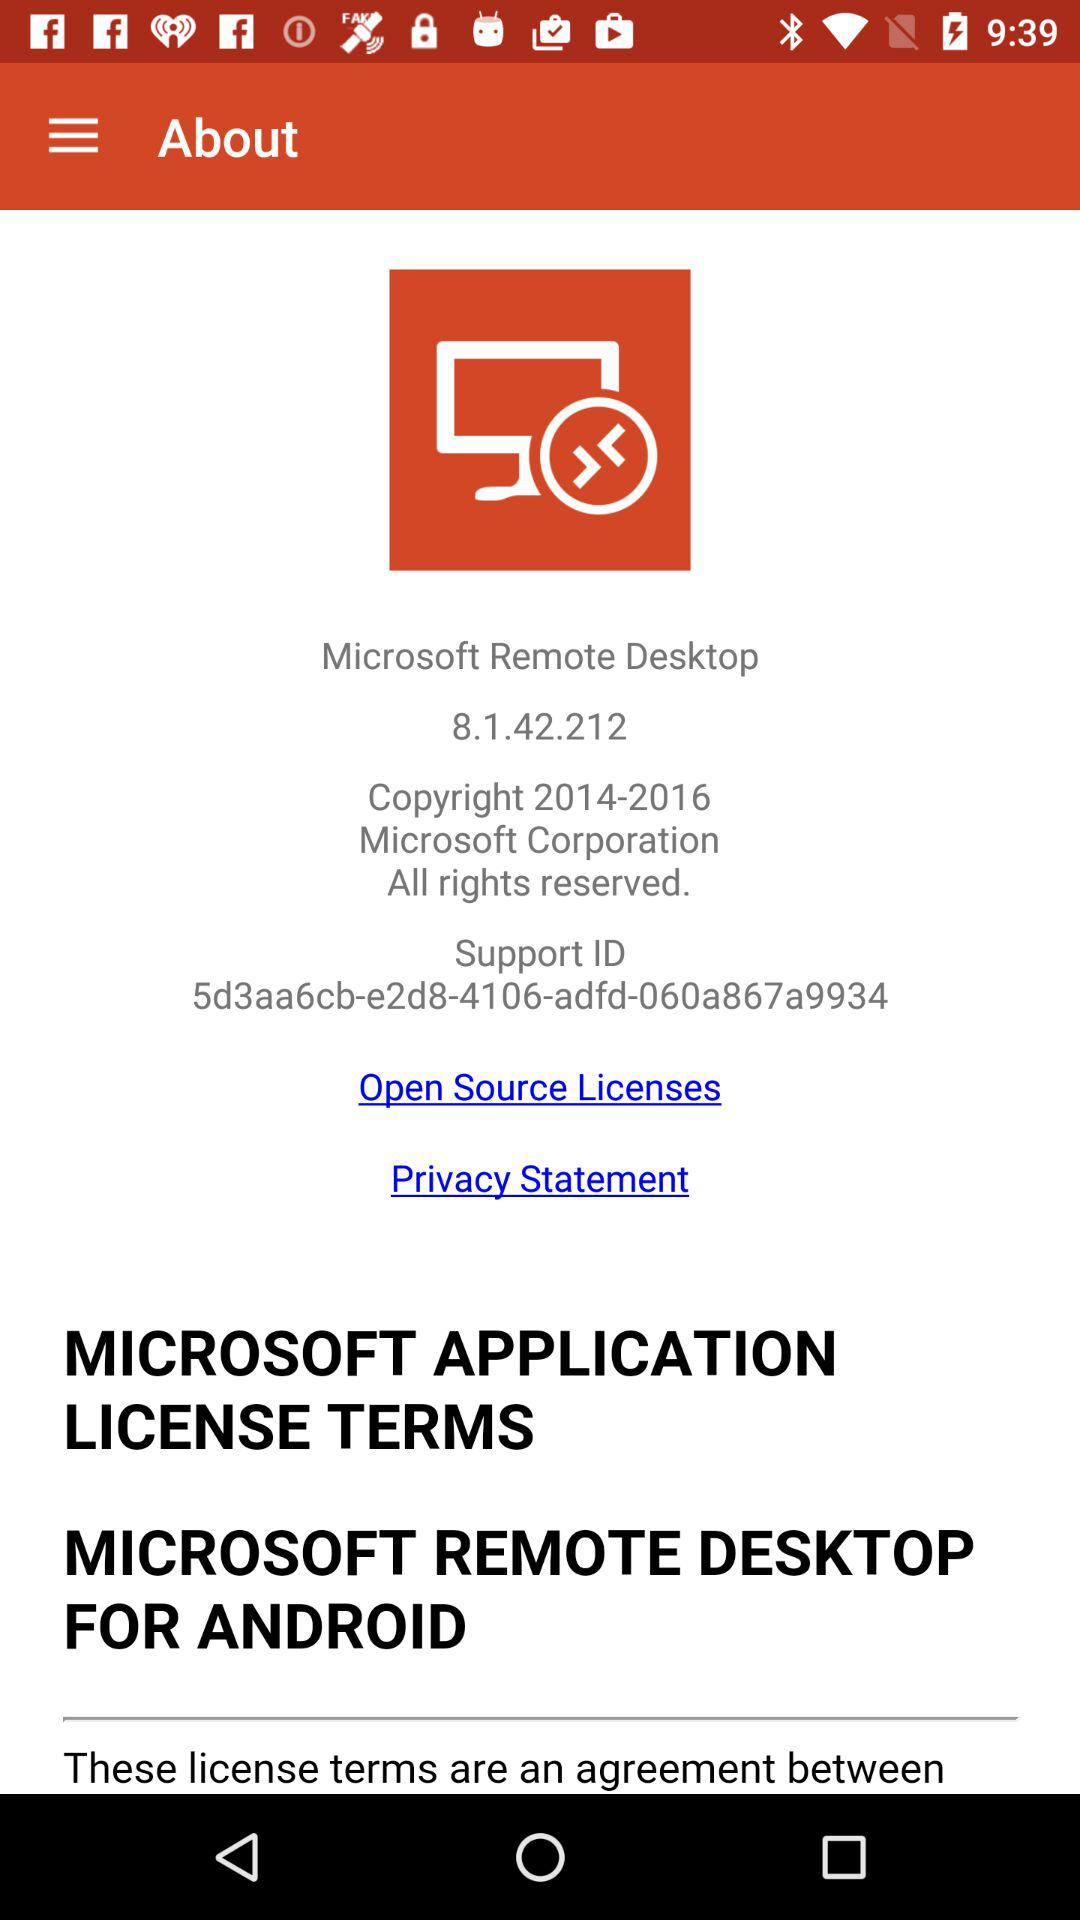What is the version? The version is 8.1.42.212. 